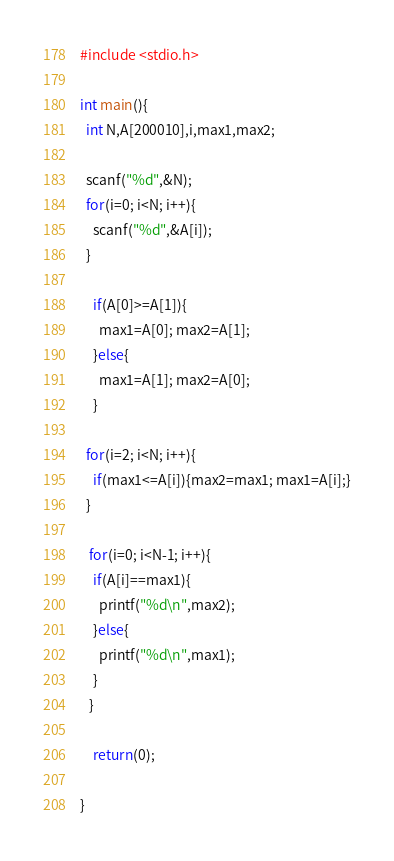<code> <loc_0><loc_0><loc_500><loc_500><_C_>#include <stdio.h>

int main(){
  int N,A[200010],i,max1,max2;
  
  scanf("%d",&N);
  for(i=0; i<N; i++){
  	scanf("%d",&A[i]);
  }
    
    if(A[0]>=A[1]){
      max1=A[0]; max2=A[1];
    }else{
      max1=A[1]; max2=A[0];
    }
  
  for(i=2; i<N; i++){
  	if(max1<=A[i]){max2=max1; max1=A[i];}
  }
    
   for(i=0; i<N-1; i++){
    if(A[i]==max1){
      printf("%d\n",max2);
    }else{
      printf("%d\n",max1);
    }
   }
    
    return(0);
    
}
</code> 